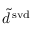Convert formula to latex. <formula><loc_0><loc_0><loc_500><loc_500>\tilde { d } ^ { \, s v d }</formula> 